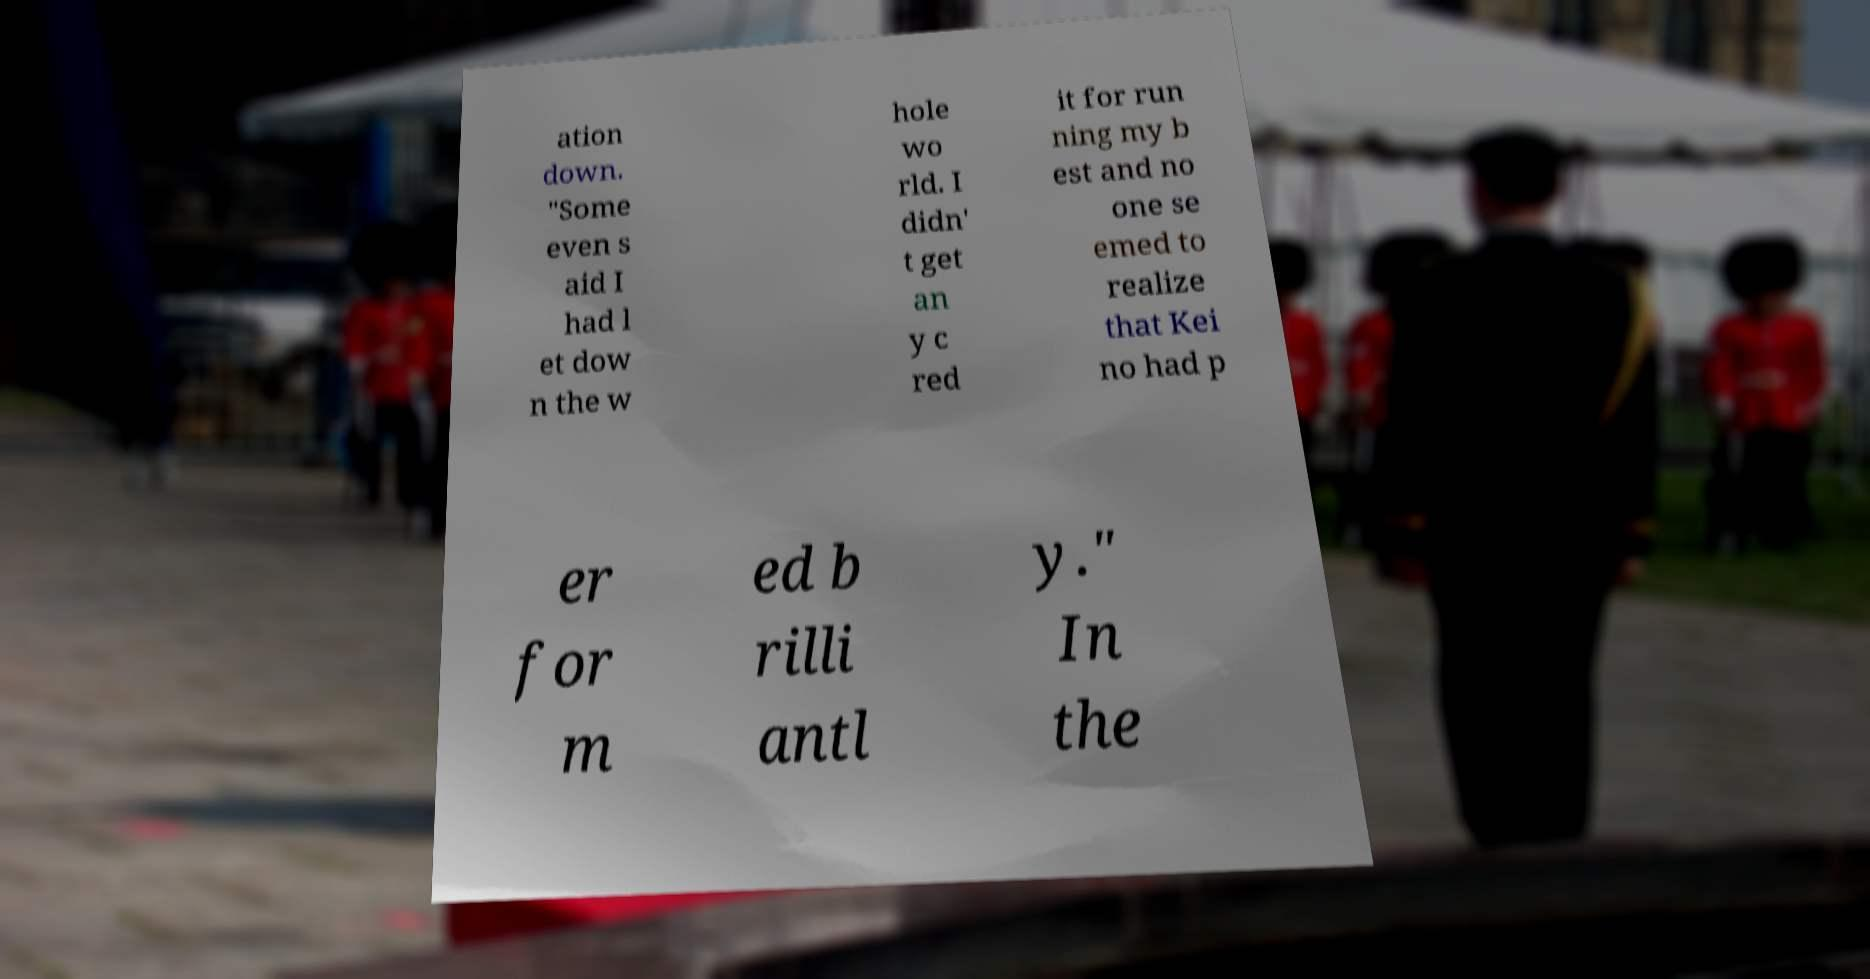What messages or text are displayed in this image? I need them in a readable, typed format. ation down. "Some even s aid I had l et dow n the w hole wo rld. I didn' t get an y c red it for run ning my b est and no one se emed to realize that Kei no had p er for m ed b rilli antl y." In the 